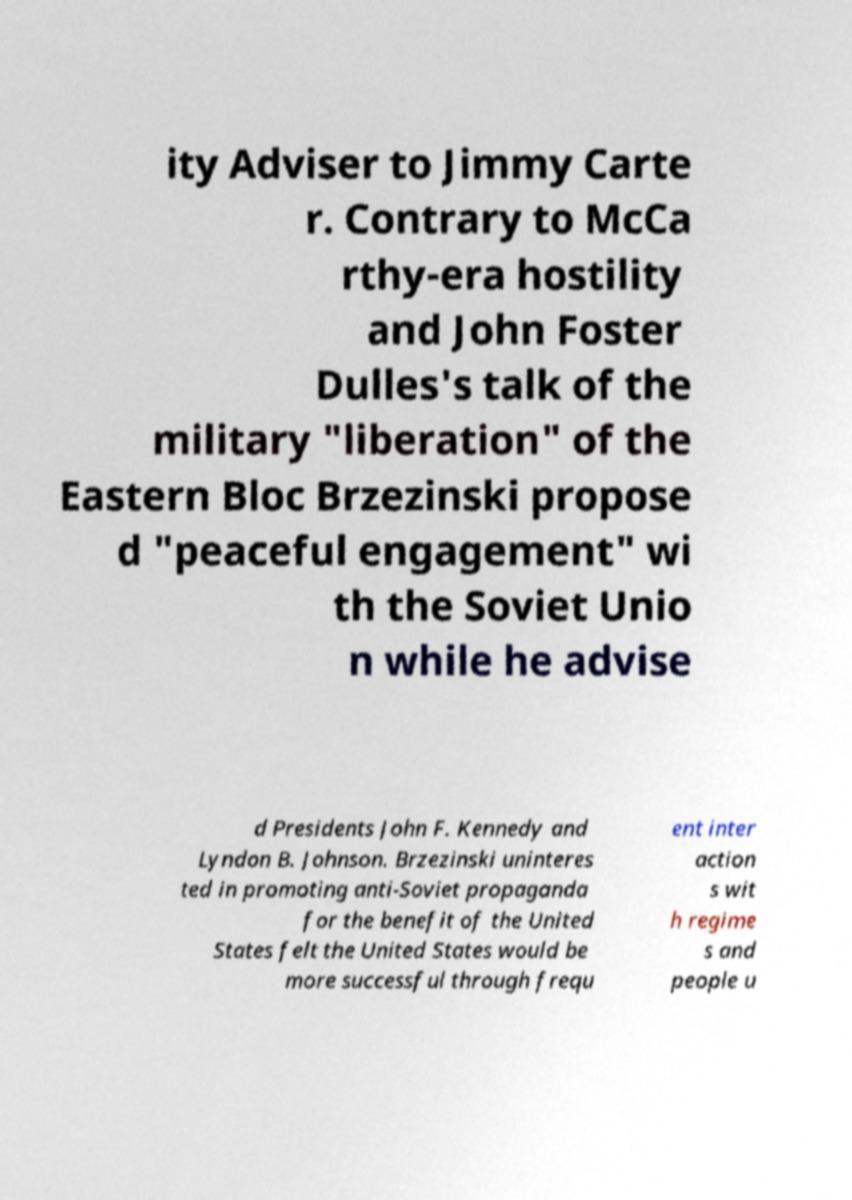Please read and relay the text visible in this image. What does it say? ity Adviser to Jimmy Carte r. Contrary to McCa rthy-era hostility and John Foster Dulles's talk of the military "liberation" of the Eastern Bloc Brzezinski propose d "peaceful engagement" wi th the Soviet Unio n while he advise d Presidents John F. Kennedy and Lyndon B. Johnson. Brzezinski uninteres ted in promoting anti-Soviet propaganda for the benefit of the United States felt the United States would be more successful through frequ ent inter action s wit h regime s and people u 